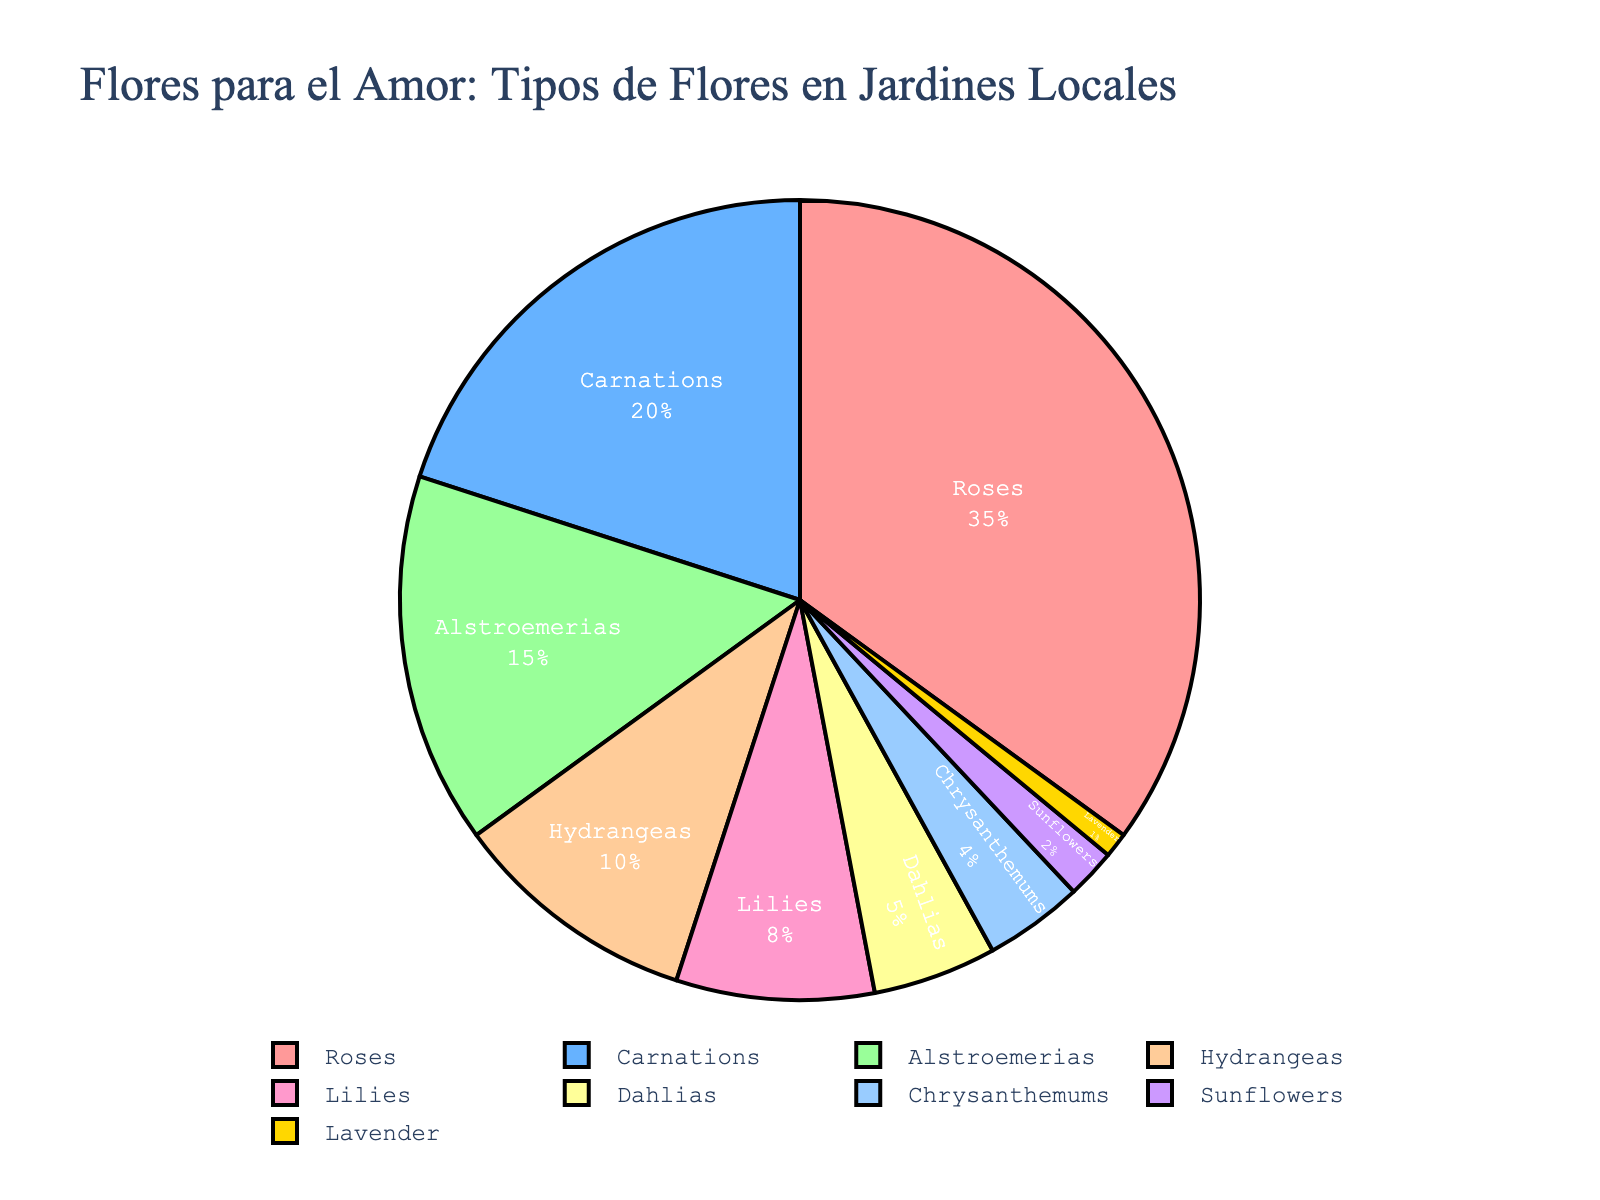Which flower type is the most common for romantic gestures in local gardens? The pie chart shows that roses have the largest segment, meaning they are the most common flowers for romantic gestures.
Answer: Roses Which flower type is the least common for romantic gestures in local gardens? The pie chart shows that lavender has the smallest segment, which makes it the least common flower for romantic gestures.
Answer: Lavender What is the combined percentage for Carnations and Alstroemerias? From the pie chart, Carnations have 20% and Alstroemerias have 15%. Adding them together gives 20% + 15% = 35%.
Answer: 35% Are there more Hydrangeas or Lilies grown for romantic gestures in local gardens? From the pie chart, Hydrangeas have 10% and Lilies have 8%. Therefore, there are more Hydrangeas than Lilies.
Answer: Hydrangeas What is the difference in percentage between Roses and Sunflowers? The pie chart shows that Roses have 35% and Sunflowers have 2%. The difference is 35% - 2% = 33%.
Answer: 33% Which flower types together make up less than 10% of the total? From the pie chart, Dahlias (5%), Chrysanthemums (4%), Sunflowers (2%), and Lavender (1%) all individually add up to less than 10%. Summing them gives 5% + 4% + 2% + 1% = 12%, but each one on its own is less than 10%.
Answer: Dahlias, Chrysanthemums, Sunflowers, Lavender What is the combined percentage for flowers with less than 5% representation each? The flowers with less than 5% are Chrysanthemums (4%), Sunflowers (2%), and Lavender (1%). Adding them together gives 4% + 2% + 1% = 7%.
Answer: 7% Which flower types have a percentage higher than 10%? According to the pie chart, the flower types with percentages higher than 10% are Roses (35%), Carnations (20%), and Alstroemerias (15%).
Answer: Roses, Carnations, Alstroemerias 